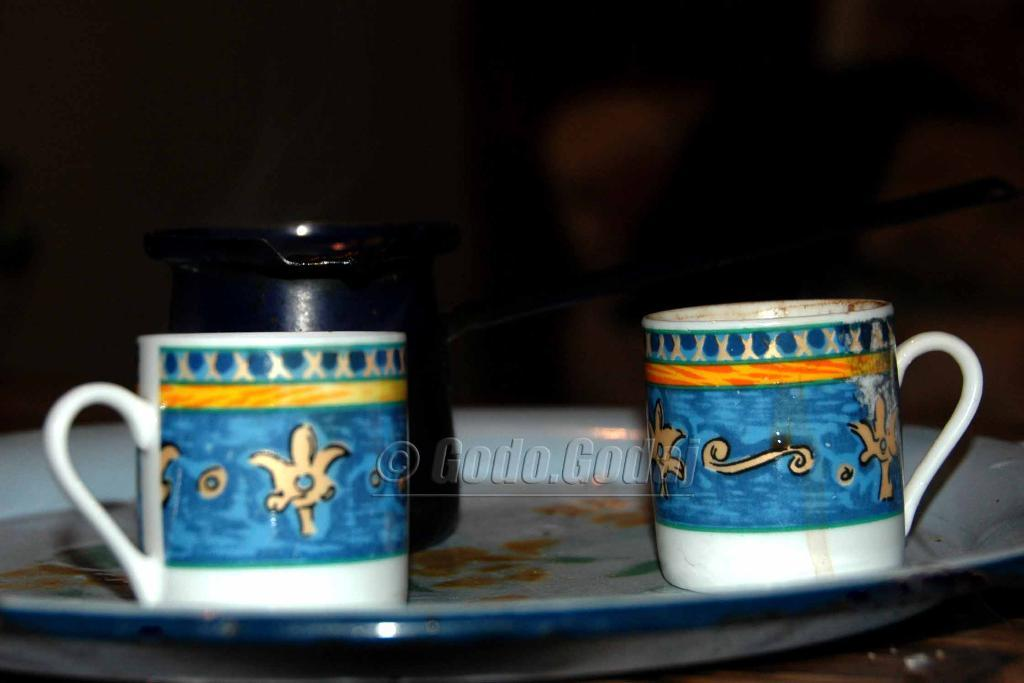What is present on the plate in the image? There are cups on the plate in the image. What other object can be seen in the image besides the plate? There is a jar in the image. Can you describe the background of the image? The background of the image is blurred. What is the limit of the lamp in the image? There is no lamp present in the image, so there is no limit to discuss. 